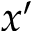Convert formula to latex. <formula><loc_0><loc_0><loc_500><loc_500>x ^ { \prime }</formula> 